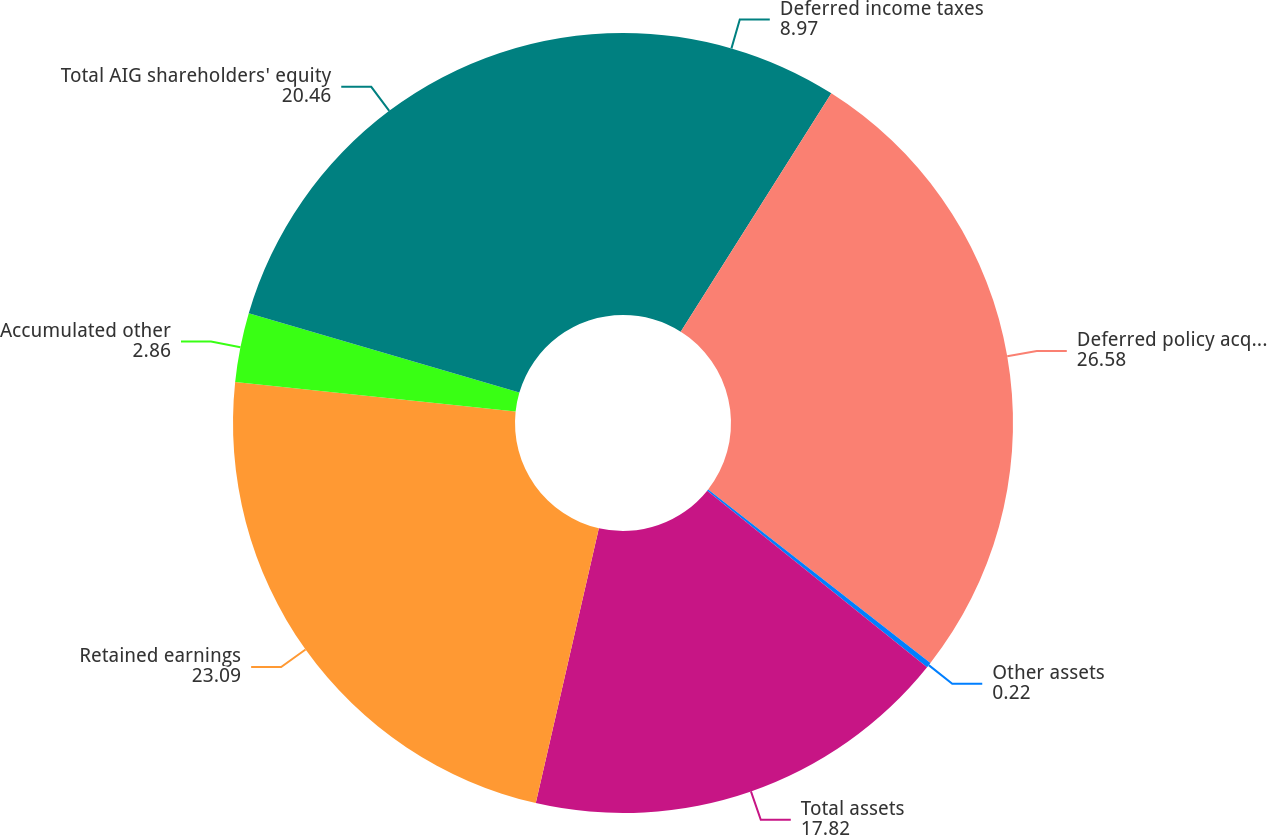Convert chart. <chart><loc_0><loc_0><loc_500><loc_500><pie_chart><fcel>Deferred income taxes<fcel>Deferred policy acquisition<fcel>Other assets<fcel>Total assets<fcel>Retained earnings<fcel>Accumulated other<fcel>Total AIG shareholders' equity<nl><fcel>8.97%<fcel>26.58%<fcel>0.22%<fcel>17.82%<fcel>23.09%<fcel>2.86%<fcel>20.46%<nl></chart> 